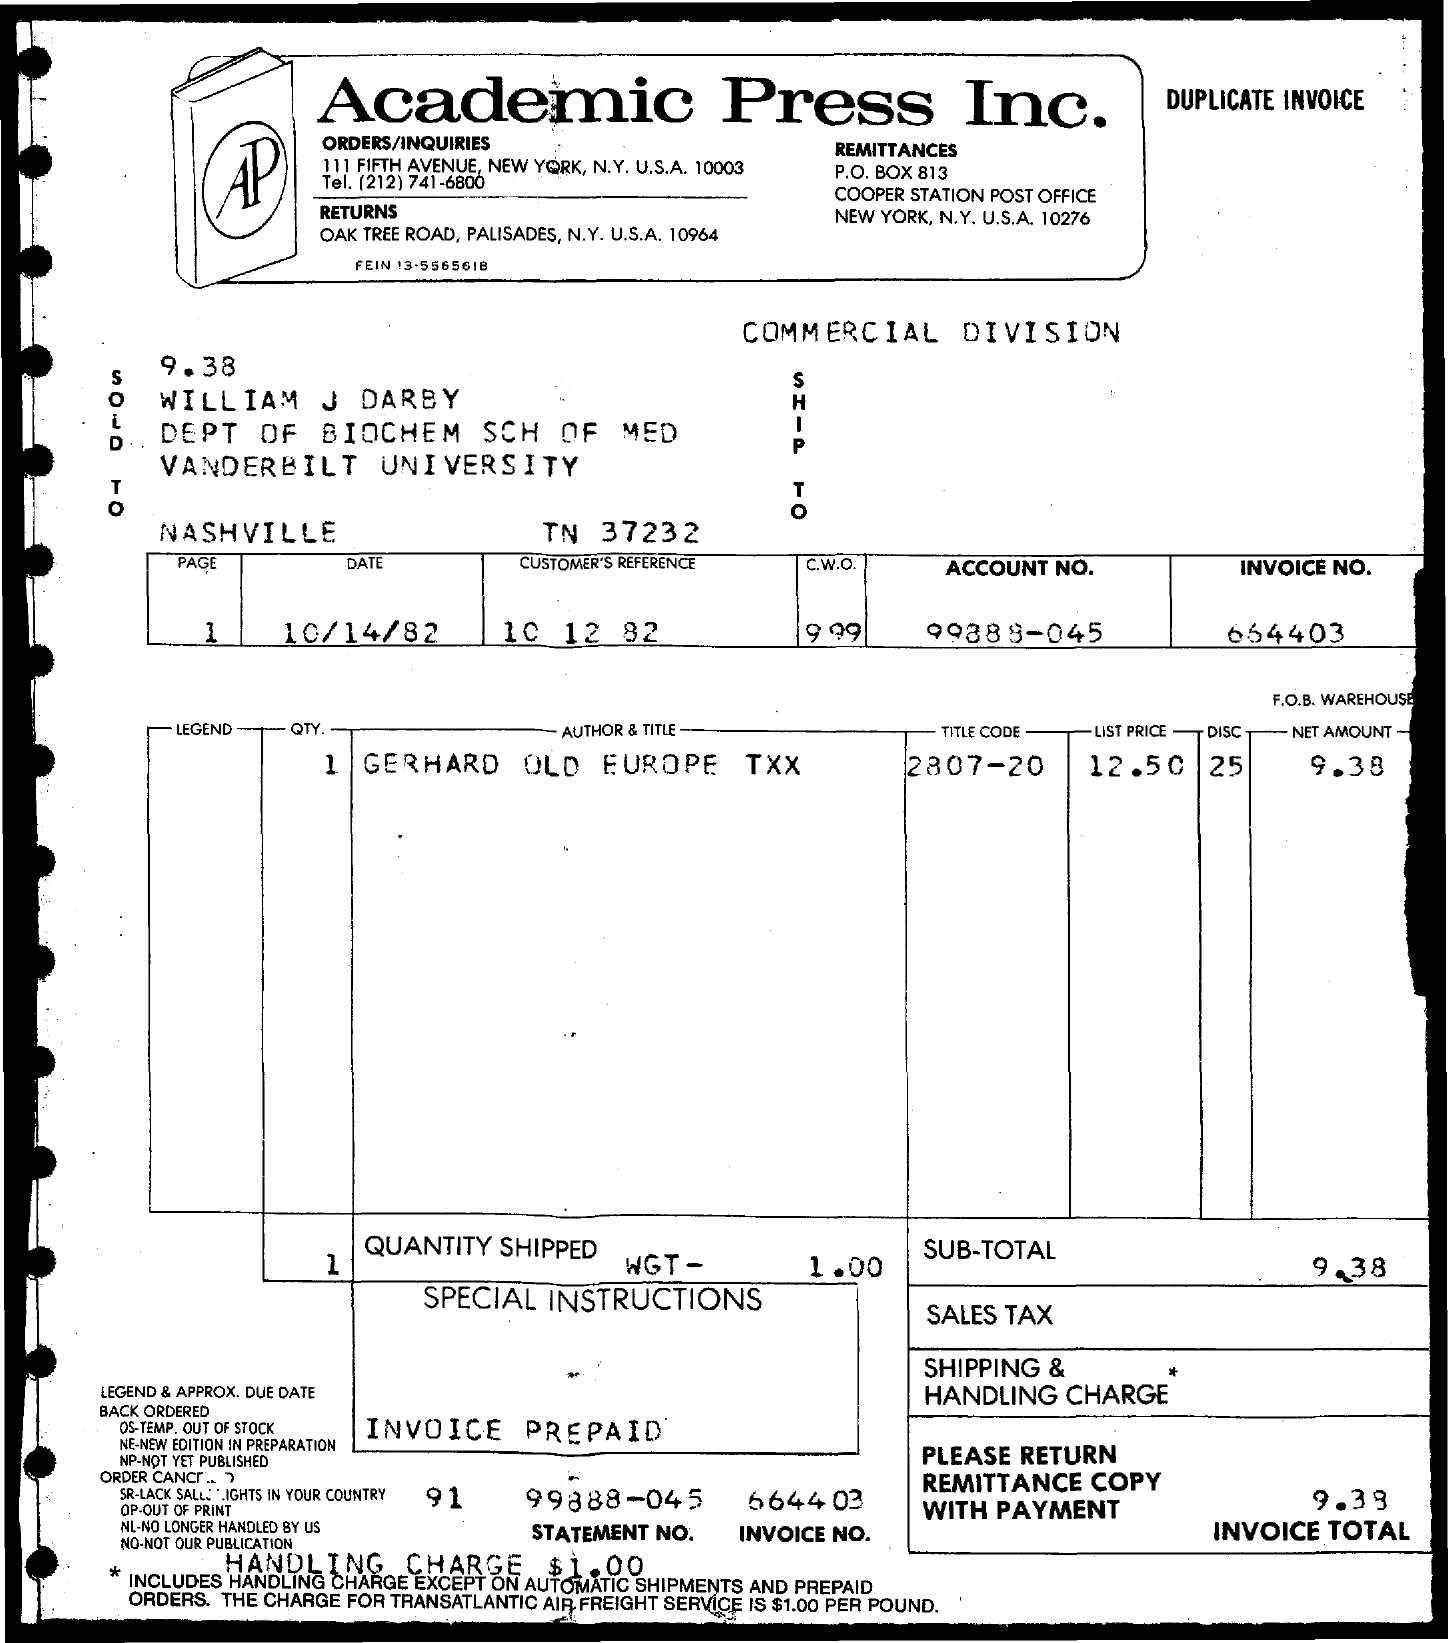Point out several critical features in this image. The list price is $12.50. The net amount is 9.38. The date is 10/14/82. The account number is 99888-045.. The customer reference includes a range of numbers from 10 to 82. 